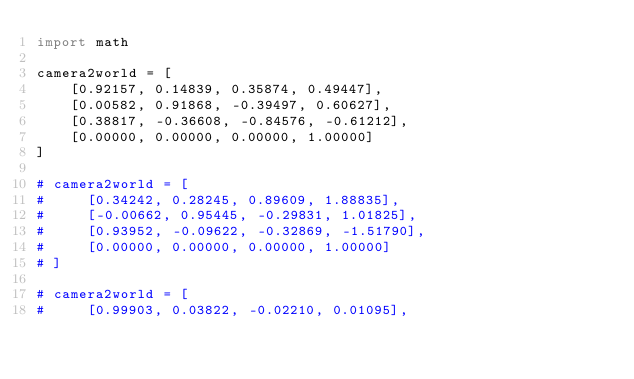<code> <loc_0><loc_0><loc_500><loc_500><_Python_>import math

camera2world = [
    [0.92157, 0.14839, 0.35874, 0.49447],
    [0.00582, 0.91868, -0.39497, 0.60627],
    [0.38817, -0.36608, -0.84576, -0.61212],
    [0.00000, 0.00000, 0.00000, 1.00000]
]

# camera2world = [
#     [0.34242, 0.28245, 0.89609, 1.88835],
#     [-0.00662, 0.95445, -0.29831, 1.01825],
#     [0.93952, -0.09622, -0.32869, -1.51790],
#     [0.00000, 0.00000, 0.00000, 1.00000]
# ]

# camera2world = [
#     [0.99903, 0.03822, -0.02210, 0.01095],</code> 